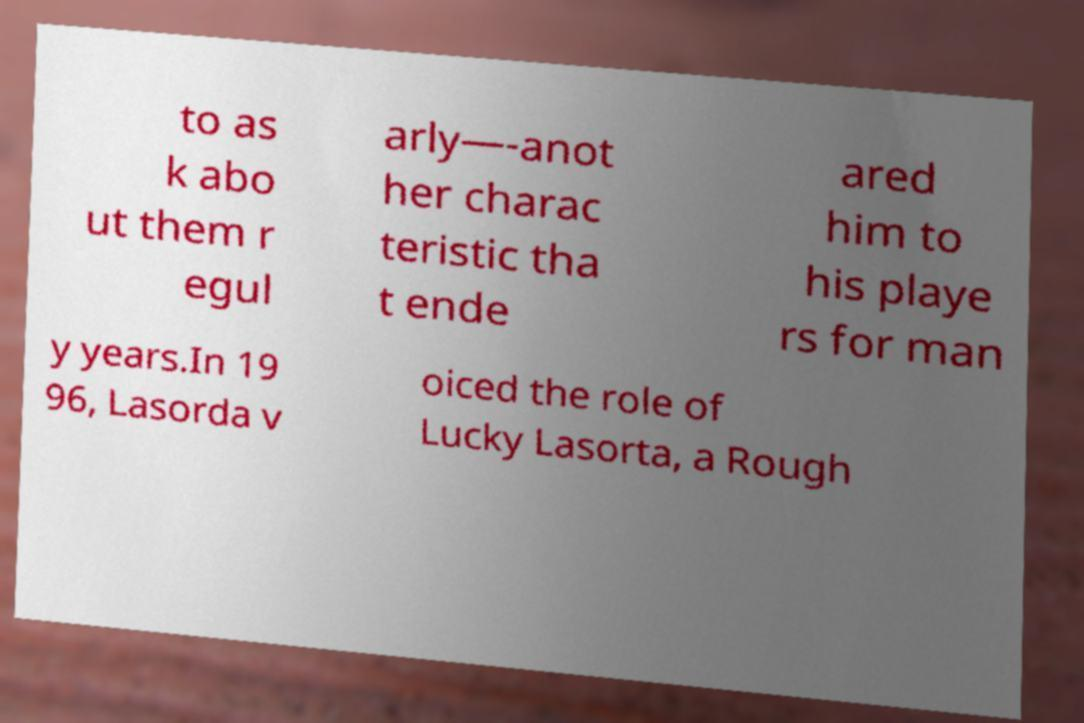Could you assist in decoding the text presented in this image and type it out clearly? to as k abo ut them r egul arly—-anot her charac teristic tha t ende ared him to his playe rs for man y years.In 19 96, Lasorda v oiced the role of Lucky Lasorta, a Rough 